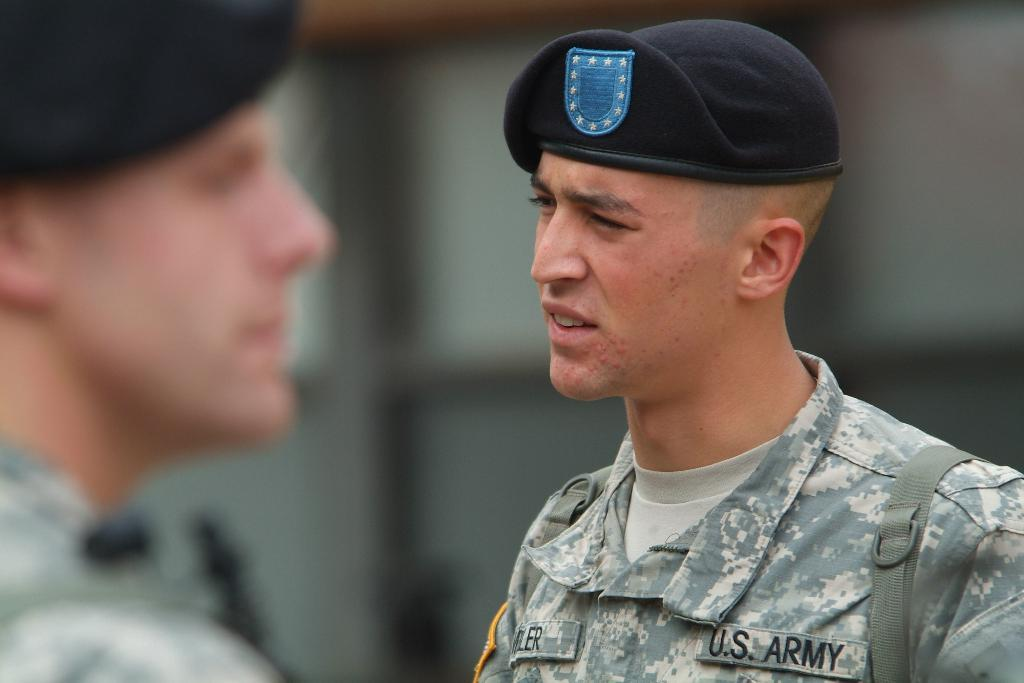Who or what is the main subject of the image? There is a person in the image. What can be observed about the background of the image? The background of the image is blurred. What is the person wearing in the image? The person is wearing clothes and a cap. Can you describe the presence of another person in the image? There is another person on the left side of the image. What type of goat can be seen attempting to climb the cap in the image? There is no goat present in the image, and therefore no such attempt can be observed. 